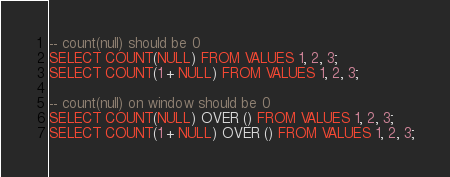Convert code to text. <code><loc_0><loc_0><loc_500><loc_500><_SQL_>
-- count(null) should be 0
SELECT COUNT(NULL) FROM VALUES 1, 2, 3;
SELECT COUNT(1 + NULL) FROM VALUES 1, 2, 3;

-- count(null) on window should be 0
SELECT COUNT(NULL) OVER () FROM VALUES 1, 2, 3;
SELECT COUNT(1 + NULL) OVER () FROM VALUES 1, 2, 3;

</code> 